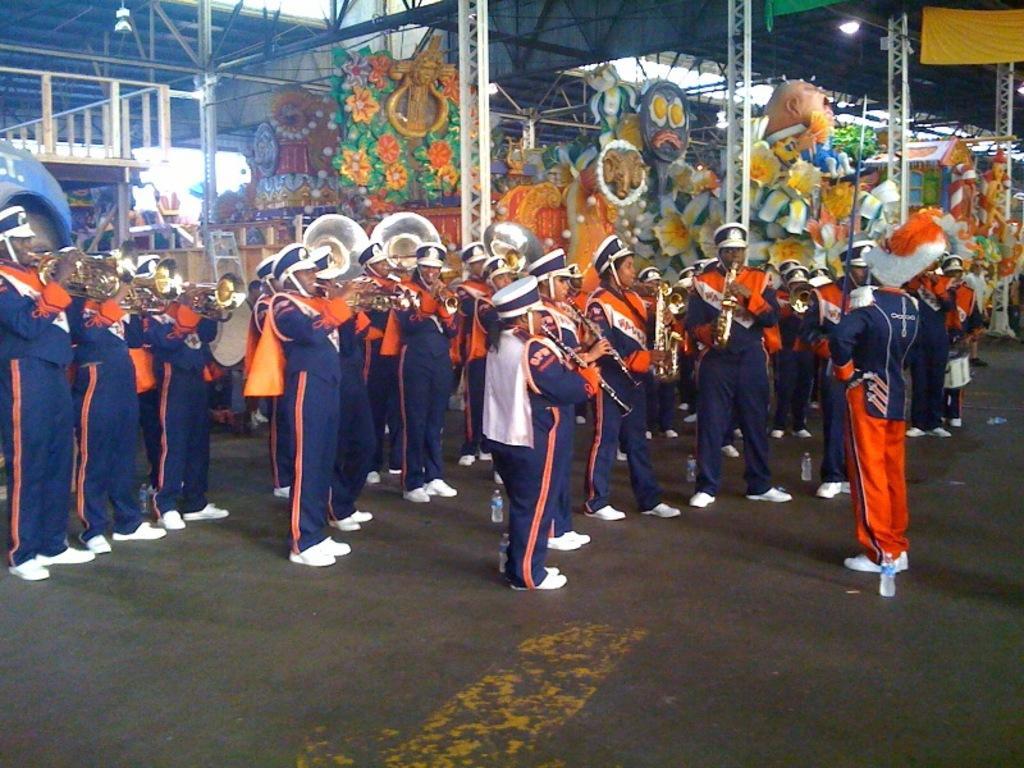How would you summarize this image in a sentence or two? In this image we can see a few people standing and playing the musical instruments, there are some pillars, lights, metal rods and some other objects. 